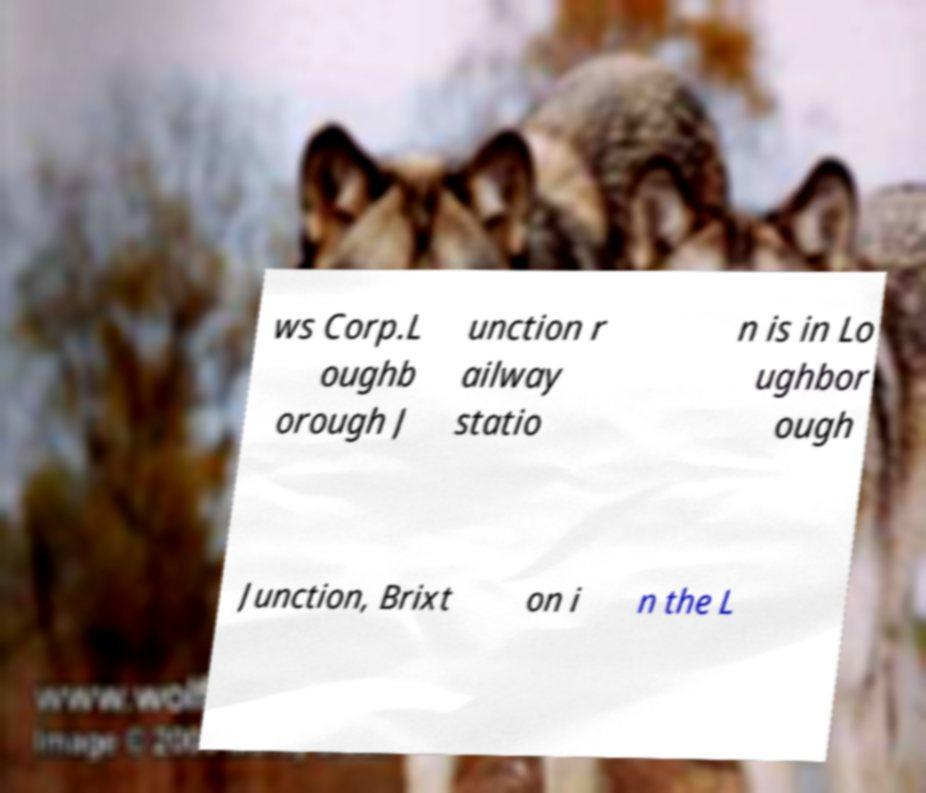There's text embedded in this image that I need extracted. Can you transcribe it verbatim? ws Corp.L oughb orough J unction r ailway statio n is in Lo ughbor ough Junction, Brixt on i n the L 